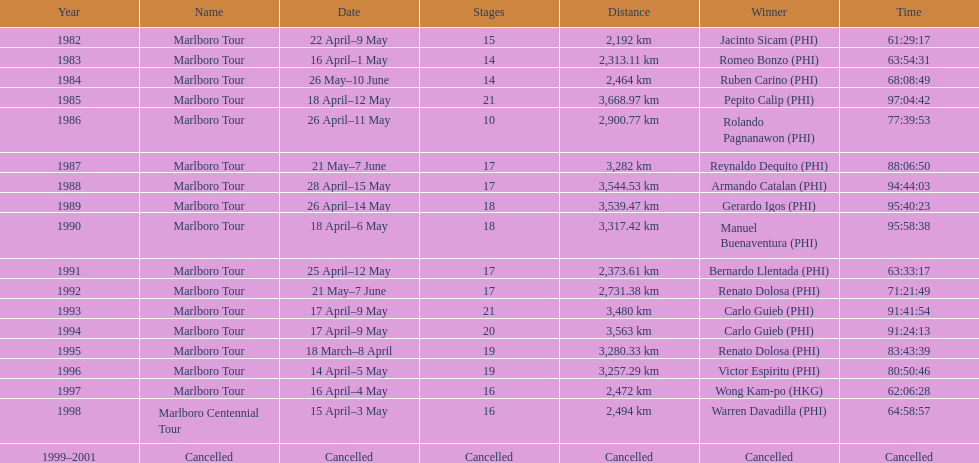What was the largest distance traveled for the marlboro tour? 3,668.97 km. 